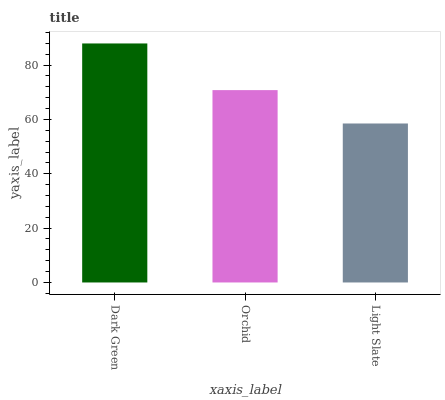Is Light Slate the minimum?
Answer yes or no. Yes. Is Dark Green the maximum?
Answer yes or no. Yes. Is Orchid the minimum?
Answer yes or no. No. Is Orchid the maximum?
Answer yes or no. No. Is Dark Green greater than Orchid?
Answer yes or no. Yes. Is Orchid less than Dark Green?
Answer yes or no. Yes. Is Orchid greater than Dark Green?
Answer yes or no. No. Is Dark Green less than Orchid?
Answer yes or no. No. Is Orchid the high median?
Answer yes or no. Yes. Is Orchid the low median?
Answer yes or no. Yes. Is Light Slate the high median?
Answer yes or no. No. Is Light Slate the low median?
Answer yes or no. No. 